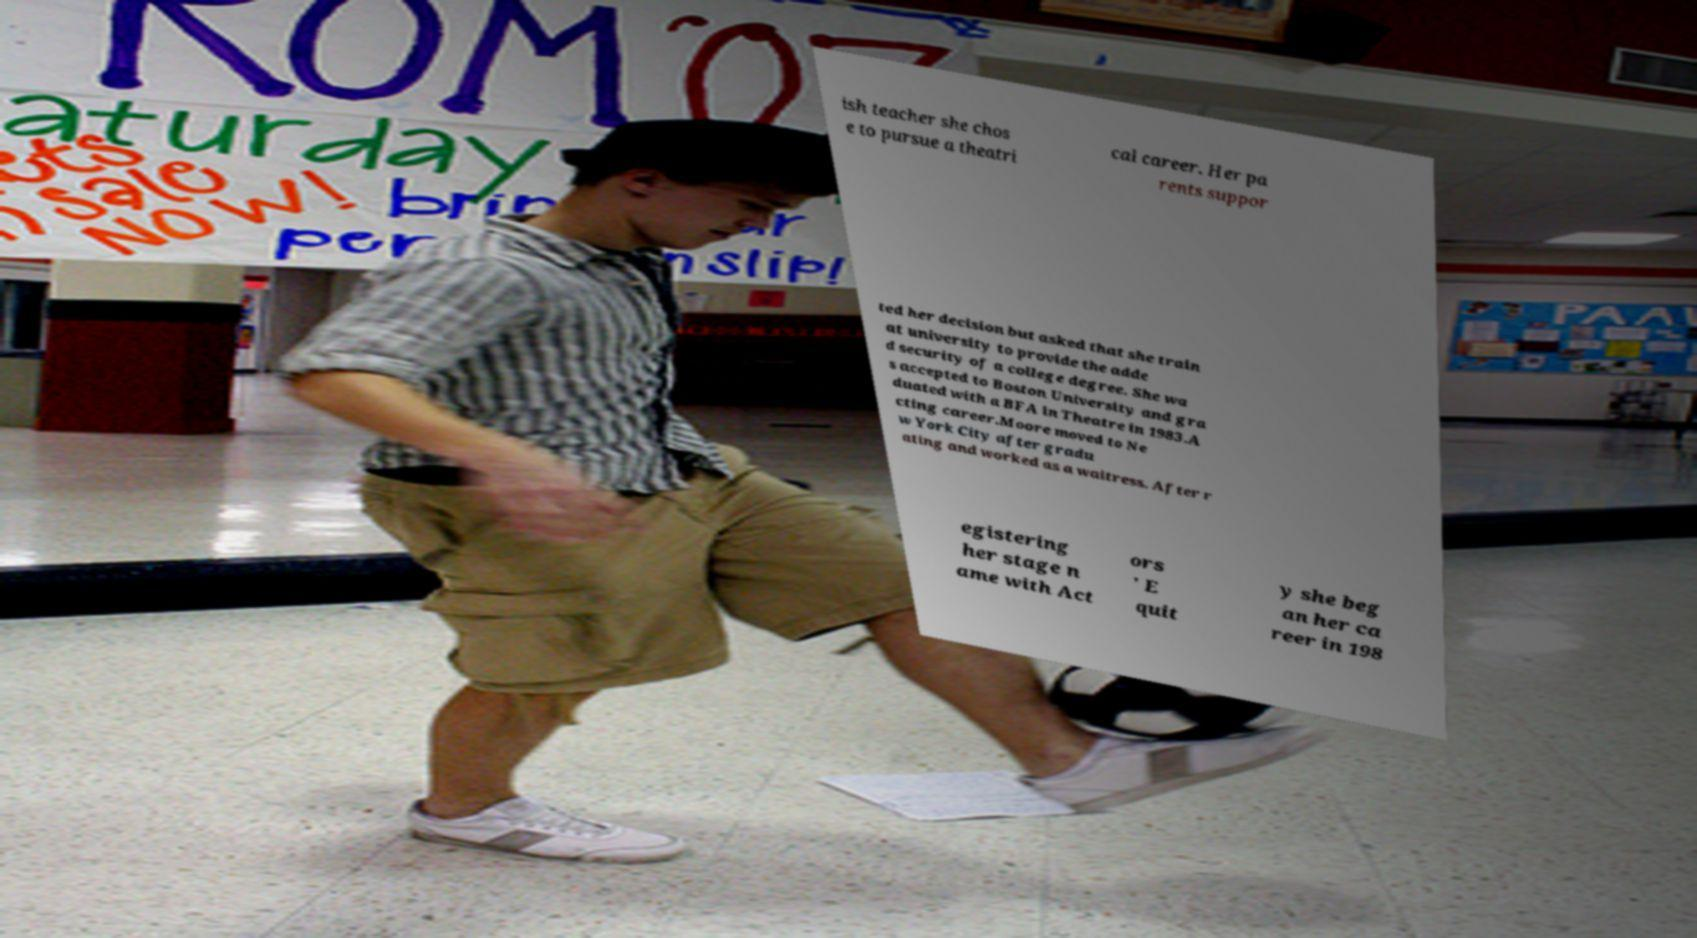Can you read and provide the text displayed in the image?This photo seems to have some interesting text. Can you extract and type it out for me? ish teacher she chos e to pursue a theatri cal career. Her pa rents suppor ted her decision but asked that she train at university to provide the adde d security of a college degree. She wa s accepted to Boston University and gra duated with a BFA in Theatre in 1983.A cting career.Moore moved to Ne w York City after gradu ating and worked as a waitress. After r egistering her stage n ame with Act ors ' E quit y she beg an her ca reer in 198 